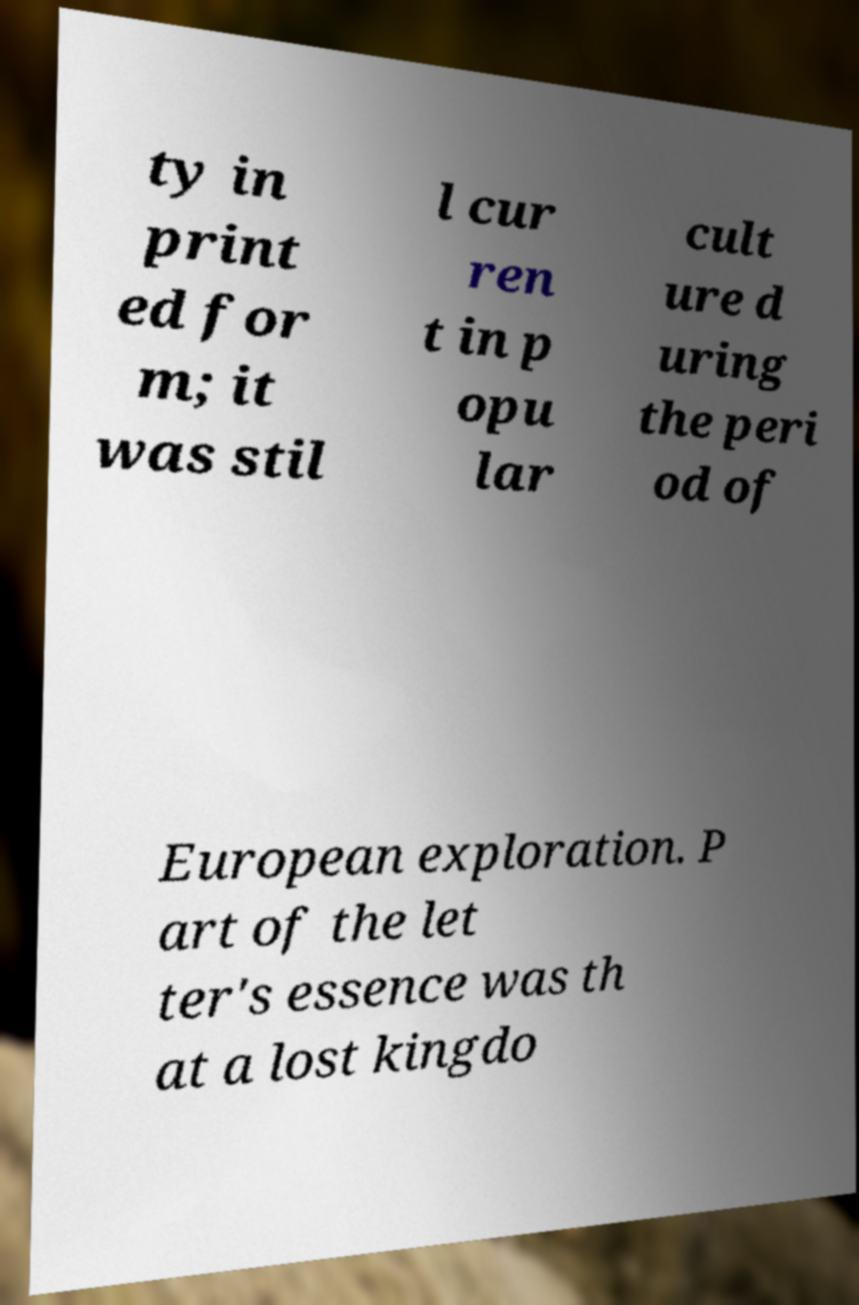Could you assist in decoding the text presented in this image and type it out clearly? ty in print ed for m; it was stil l cur ren t in p opu lar cult ure d uring the peri od of European exploration. P art of the let ter's essence was th at a lost kingdo 